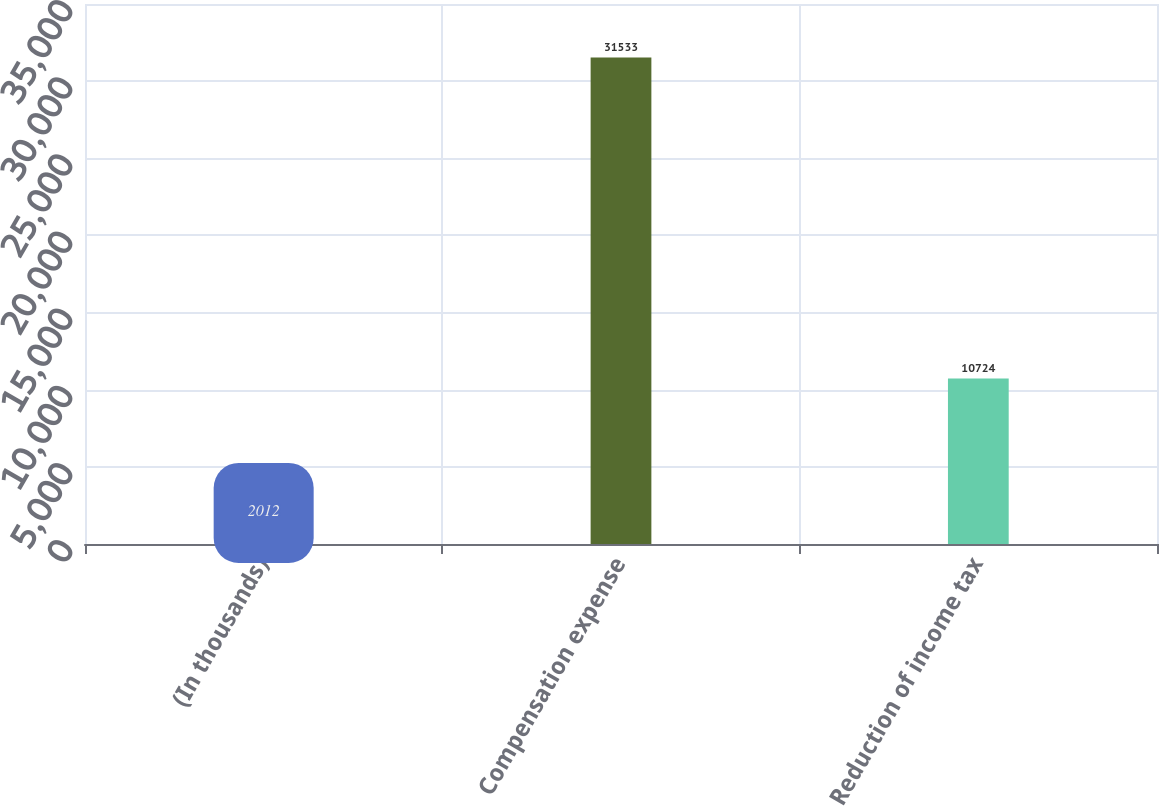Convert chart to OTSL. <chart><loc_0><loc_0><loc_500><loc_500><bar_chart><fcel>(In thousands)<fcel>Compensation expense<fcel>Reduction of income tax<nl><fcel>2012<fcel>31533<fcel>10724<nl></chart> 